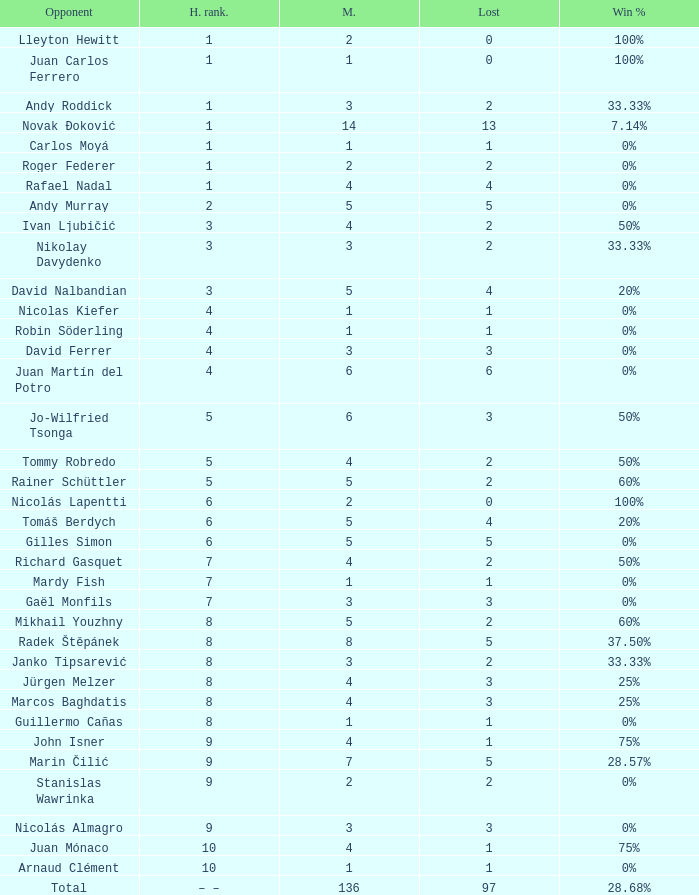What is the largest number Lost to david nalbandian with a Win Rate of 20%? 4.0. 